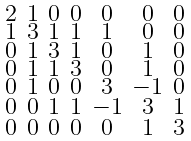<formula> <loc_0><loc_0><loc_500><loc_500>\begin{smallmatrix} 2 & 1 & 0 & 0 & 0 & 0 & 0 \\ 1 & 3 & 1 & 1 & 1 & 0 & 0 \\ 0 & 1 & 3 & 1 & 0 & 1 & 0 \\ 0 & 1 & 1 & 3 & 0 & 1 & 0 \\ 0 & 1 & 0 & 0 & 3 & - 1 & 0 \\ 0 & 0 & 1 & 1 & - 1 & 3 & 1 \\ 0 & 0 & 0 & 0 & 0 & 1 & 3 \end{smallmatrix}</formula> 